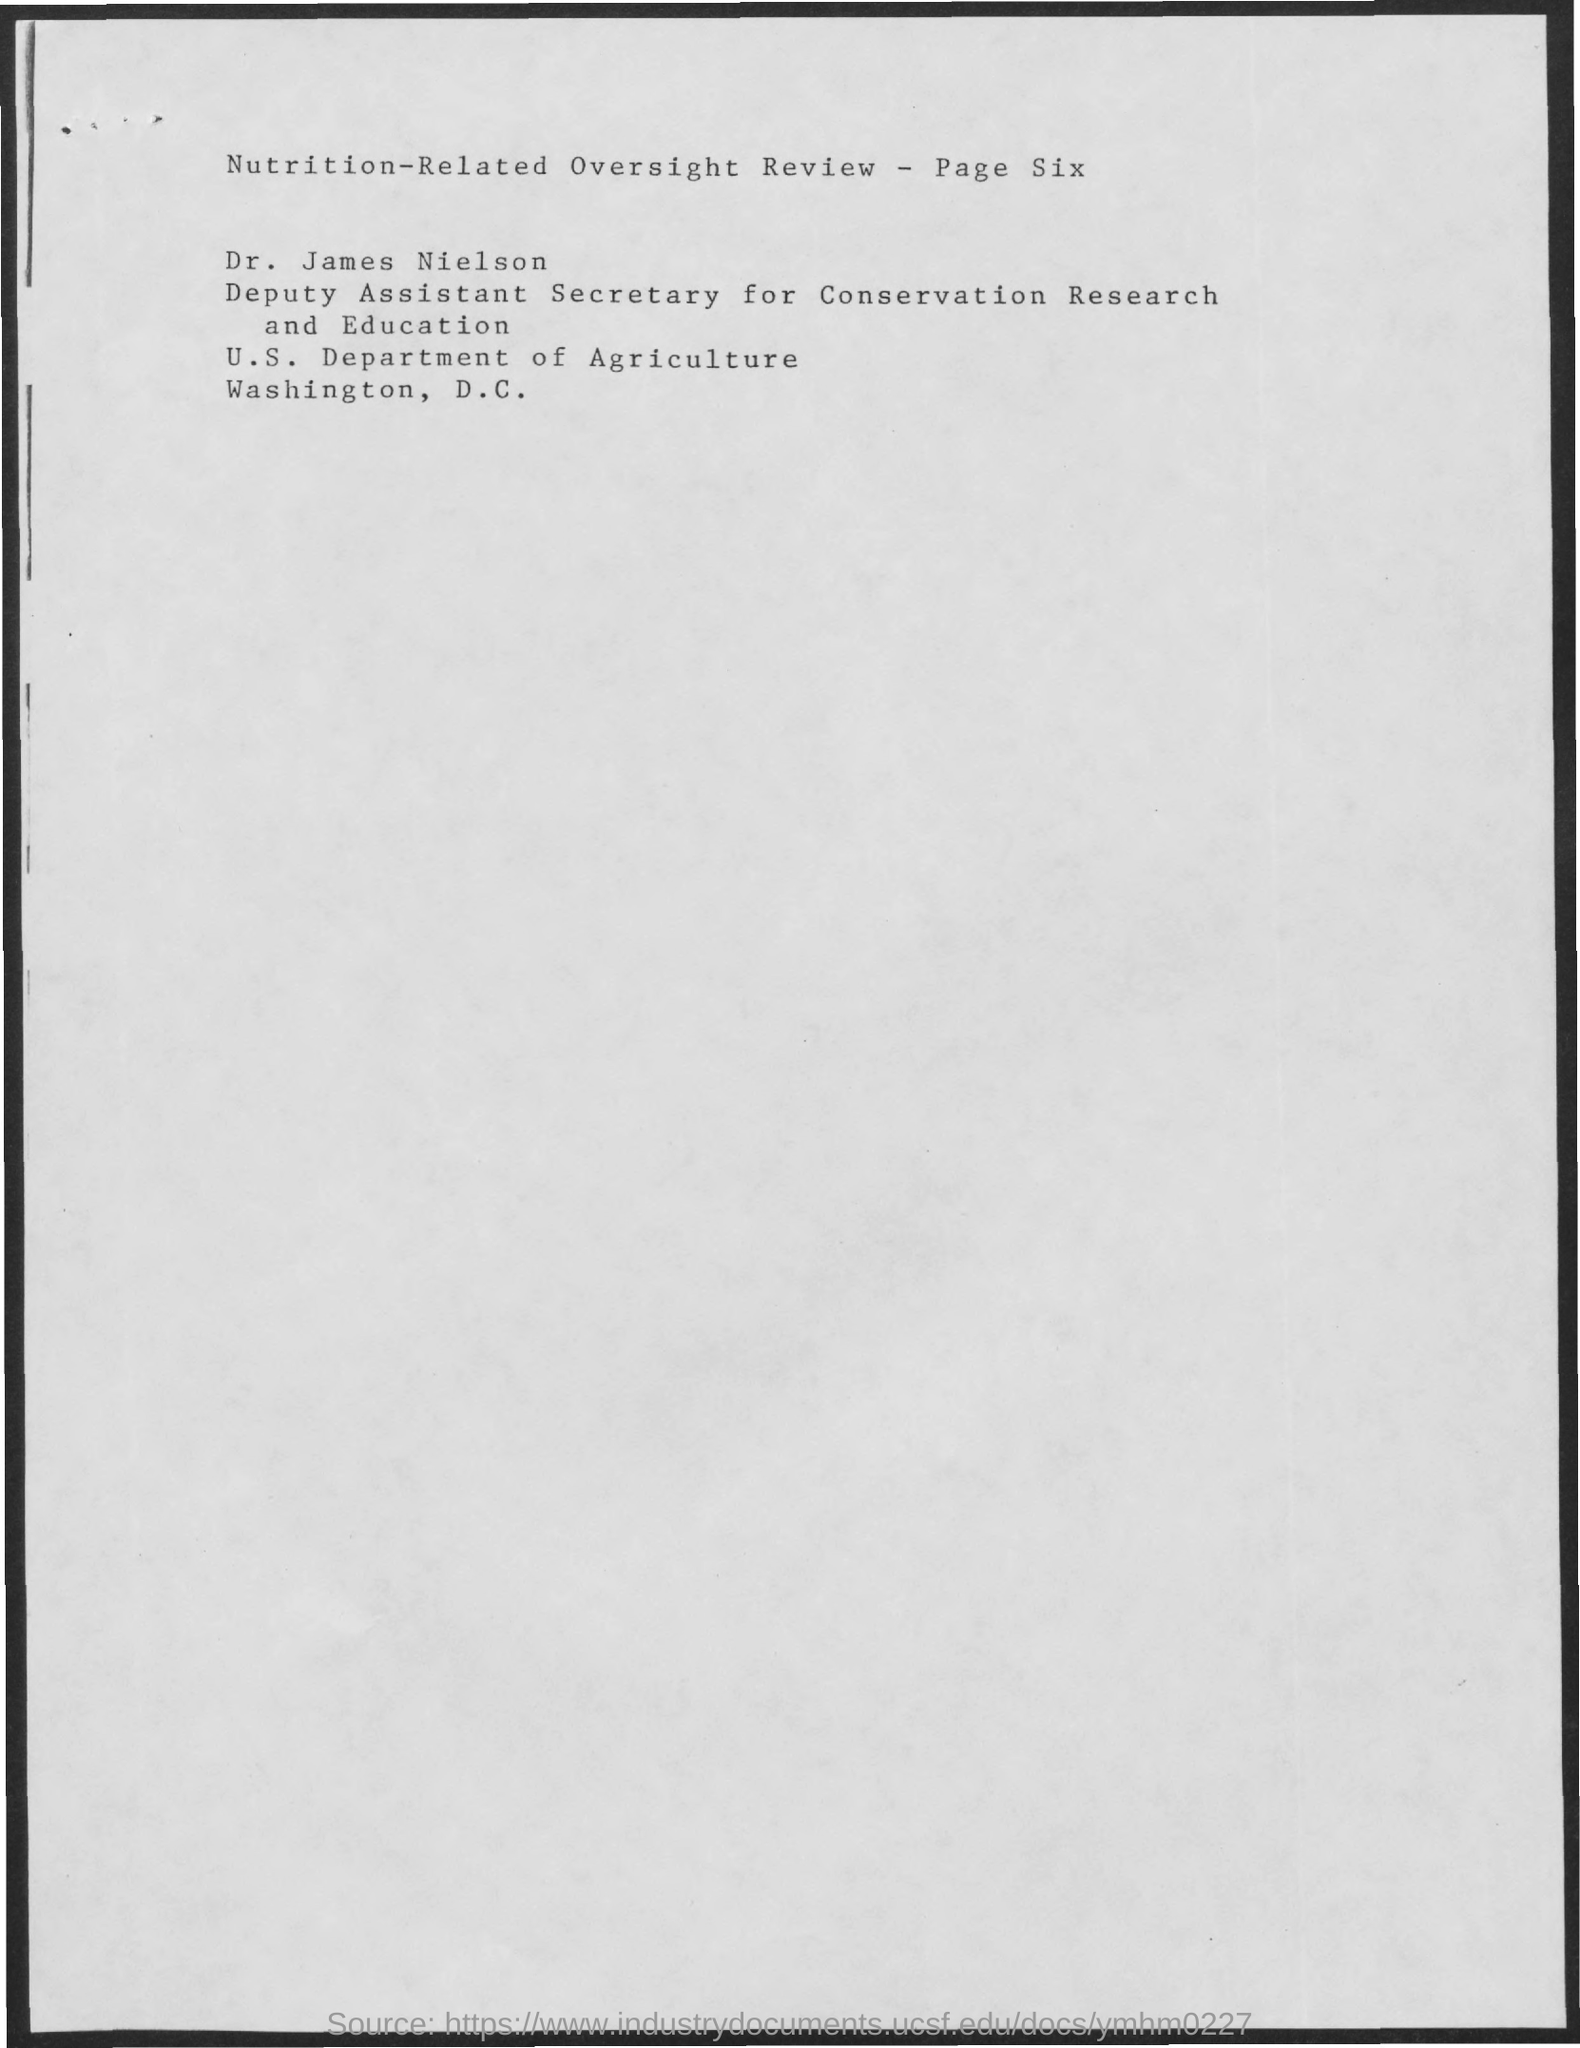Specify some key components in this picture. This review focuses on the oversight of nutrition-related matters. Dr. James Nielson holds the designation of Deputy Assistant Secretary for Conservation Research and Education. The U.S. Department of Agriculture is located in the city of Washington, D.C. The page number is six," the speaker declared. Dr. James Neilson works for the U.S. Department of Agriculture. 